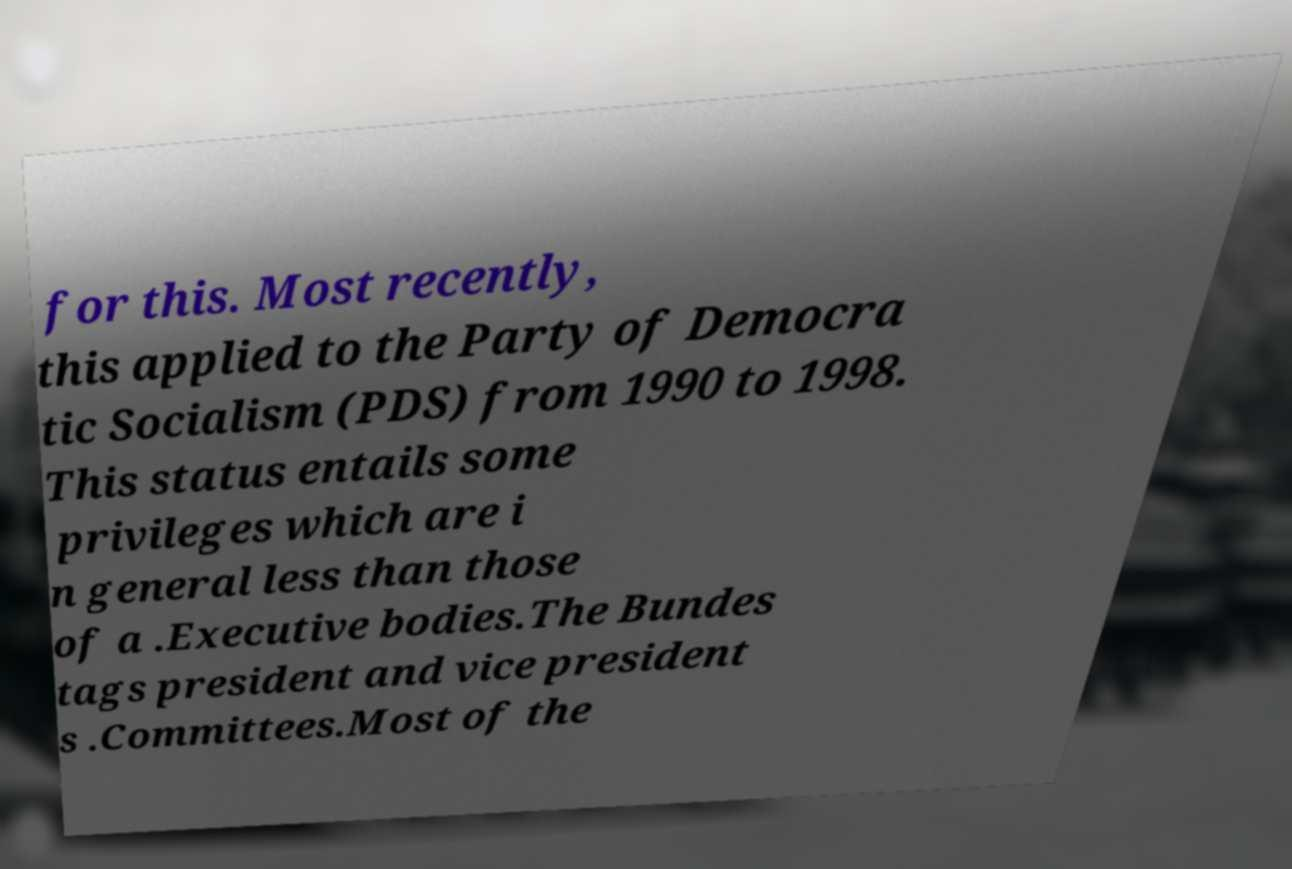There's text embedded in this image that I need extracted. Can you transcribe it verbatim? for this. Most recently, this applied to the Party of Democra tic Socialism (PDS) from 1990 to 1998. This status entails some privileges which are i n general less than those of a .Executive bodies.The Bundes tags president and vice president s .Committees.Most of the 